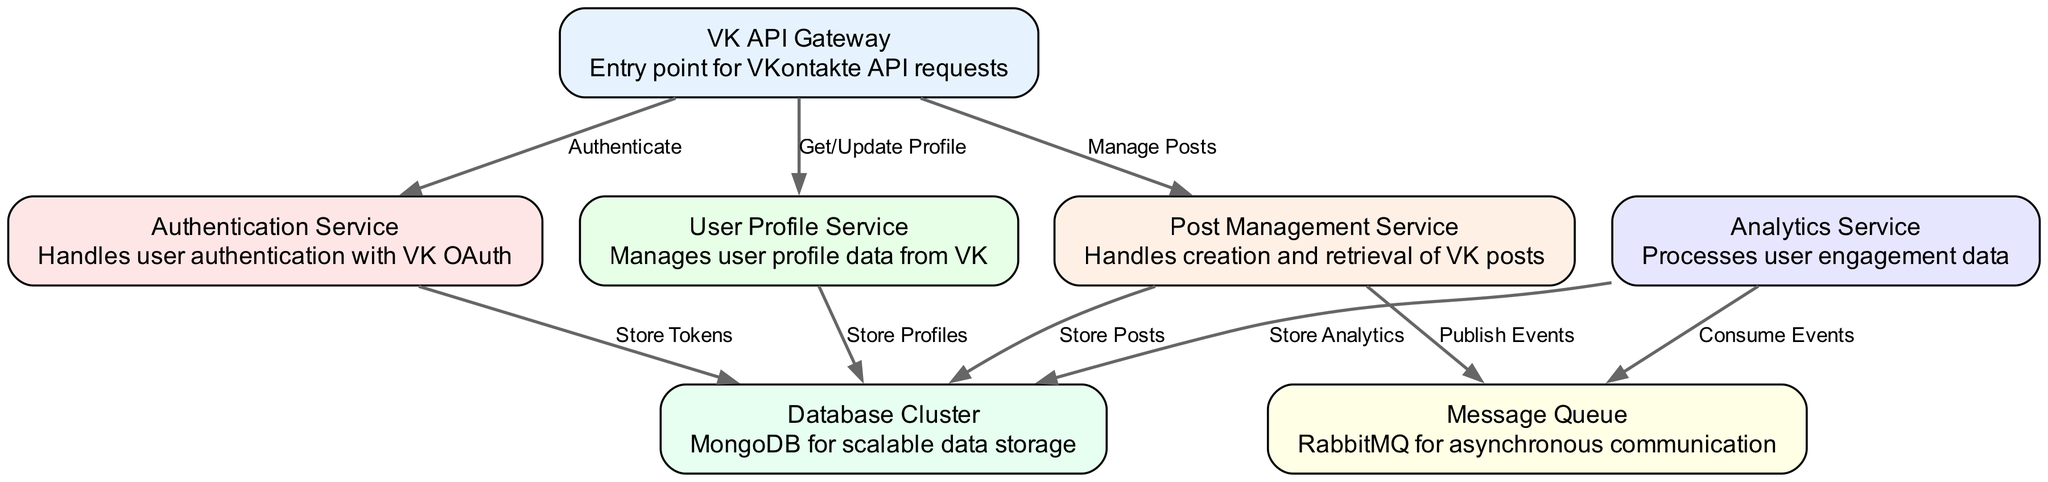What is the entry point for VKontakte API requests? The diagram indicates that the "VK API Gateway" serves as the entry point for all VKontakte API requests.
Answer: VK API Gateway How many nodes are present in the diagram? By counting each distinct node listed in the data, there are a total of 7 nodes in the diagram.
Answer: 7 Which service handles user authentication with VK OAuth? The "Authentication Service" is specifically designed to handle user authentication utilizing VK OAuth, as indicated by its description in the diagram.
Answer: Authentication Service What is the purpose of the Message Queue? The diagram states that the "Message Queue" utilizes RabbitMQ for asynchronous communication, indicating that its purpose is to facilitate this type of communication between services.
Answer: Asynchronous communication What data does the Post Management Service store? According to the diagram, the "Post Management Service" is responsible for storing posts, as indicated by its connection to the Database Cluster with the label "Store Posts."
Answer: Store Posts Which service consumes events from the Message Queue? The "Analytics Service" is shown as consuming events from the Message Queue, which is illustrated by the direct edge from the Analytics Service to the Message Queue with the label "Consume Events."
Answer: Analytics Service How do the Authentication Service and Database Cluster interact? The "Authentication Service" connects to the "Database Cluster" to store tokens, demonstrated by the labeled edge "Store Tokens" from the Authentication Service to the Database Cluster.
Answer: Store Tokens What type of data does the Analytics Service store? The diagram indicates that the "Analytics Service" is linked to the Database Cluster and is tasked with storing analytics data, as suggested by the edge labeled "Store Analytics."
Answer: Store Analytics Which services are connected directly to the Message Queue? Both the "Post Management Service" and the "Analytics Service" are connected directly to the Message Queue, as indicated by their respective edges labeled "Publish Events" and "Consume Events."
Answer: Post Management Service, Analytics Service 